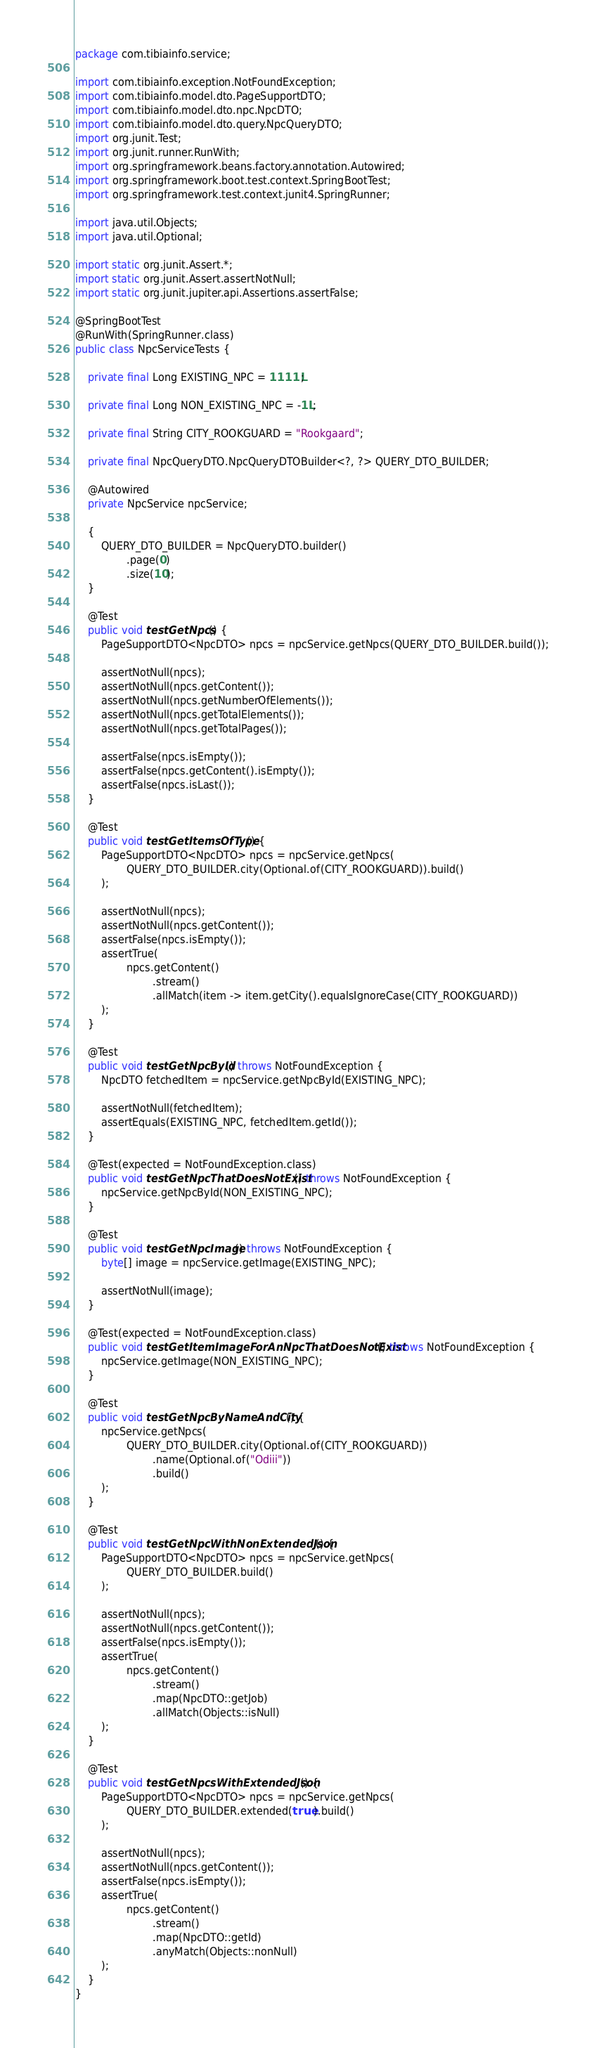Convert code to text. <code><loc_0><loc_0><loc_500><loc_500><_Java_>package com.tibiainfo.service;

import com.tibiainfo.exception.NotFoundException;
import com.tibiainfo.model.dto.PageSupportDTO;
import com.tibiainfo.model.dto.npc.NpcDTO;
import com.tibiainfo.model.dto.query.NpcQueryDTO;
import org.junit.Test;
import org.junit.runner.RunWith;
import org.springframework.beans.factory.annotation.Autowired;
import org.springframework.boot.test.context.SpringBootTest;
import org.springframework.test.context.junit4.SpringRunner;

import java.util.Objects;
import java.util.Optional;

import static org.junit.Assert.*;
import static org.junit.Assert.assertNotNull;
import static org.junit.jupiter.api.Assertions.assertFalse;

@SpringBootTest
@RunWith(SpringRunner.class)
public class NpcServiceTests {

    private final Long EXISTING_NPC = 1111L;

    private final Long NON_EXISTING_NPC = -1L;

    private final String CITY_ROOKGUARD = "Rookgaard";

    private final NpcQueryDTO.NpcQueryDTOBuilder<?, ?> QUERY_DTO_BUILDER;

    @Autowired
    private NpcService npcService;

    {
        QUERY_DTO_BUILDER = NpcQueryDTO.builder()
                .page(0)
                .size(10);
    }

    @Test
    public void testGetNpcs() {
        PageSupportDTO<NpcDTO> npcs = npcService.getNpcs(QUERY_DTO_BUILDER.build());

        assertNotNull(npcs);
        assertNotNull(npcs.getContent());
        assertNotNull(npcs.getNumberOfElements());
        assertNotNull(npcs.getTotalElements());
        assertNotNull(npcs.getTotalPages());

        assertFalse(npcs.isEmpty());
        assertFalse(npcs.getContent().isEmpty());
        assertFalse(npcs.isLast());
    }

    @Test
    public void testGetItemsOfType() {
        PageSupportDTO<NpcDTO> npcs = npcService.getNpcs(
                QUERY_DTO_BUILDER.city(Optional.of(CITY_ROOKGUARD)).build()
        );

        assertNotNull(npcs);
        assertNotNull(npcs.getContent());
        assertFalse(npcs.isEmpty());
        assertTrue(
                npcs.getContent()
                        .stream()
                        .allMatch(item -> item.getCity().equalsIgnoreCase(CITY_ROOKGUARD))
        );
    }

    @Test
    public void testGetNpcById() throws NotFoundException {
        NpcDTO fetchedItem = npcService.getNpcById(EXISTING_NPC);

        assertNotNull(fetchedItem);
        assertEquals(EXISTING_NPC, fetchedItem.getId());
    }

    @Test(expected = NotFoundException.class)
    public void testGetNpcThatDoesNotExist() throws NotFoundException {
        npcService.getNpcById(NON_EXISTING_NPC);
    }

    @Test
    public void testGetNpcImage() throws NotFoundException {
        byte[] image = npcService.getImage(EXISTING_NPC);

        assertNotNull(image);
    }

    @Test(expected = NotFoundException.class)
    public void testGetItemImageForAnNpcThatDoesNotExist() throws NotFoundException {
        npcService.getImage(NON_EXISTING_NPC);
    }

    @Test
    public void testGetNpcByNameAndCity() {
        npcService.getNpcs(
                QUERY_DTO_BUILDER.city(Optional.of(CITY_ROOKGUARD))
                        .name(Optional.of("Odiii"))
                        .build()
        );
    }

    @Test
    public void testGetNpcWithNonExtendedJson() {
        PageSupportDTO<NpcDTO> npcs = npcService.getNpcs(
                QUERY_DTO_BUILDER.build()
        );

        assertNotNull(npcs);
        assertNotNull(npcs.getContent());
        assertFalse(npcs.isEmpty());
        assertTrue(
                npcs.getContent()
                        .stream()
                        .map(NpcDTO::getJob)
                        .allMatch(Objects::isNull)
        );
    }

    @Test
    public void testGetNpcsWithExtendedJson() {
        PageSupportDTO<NpcDTO> npcs = npcService.getNpcs(
                QUERY_DTO_BUILDER.extended(true).build()
        );

        assertNotNull(npcs);
        assertNotNull(npcs.getContent());
        assertFalse(npcs.isEmpty());
        assertTrue(
                npcs.getContent()
                        .stream()
                        .map(NpcDTO::getId)
                        .anyMatch(Objects::nonNull)
        );
    }
}
</code> 